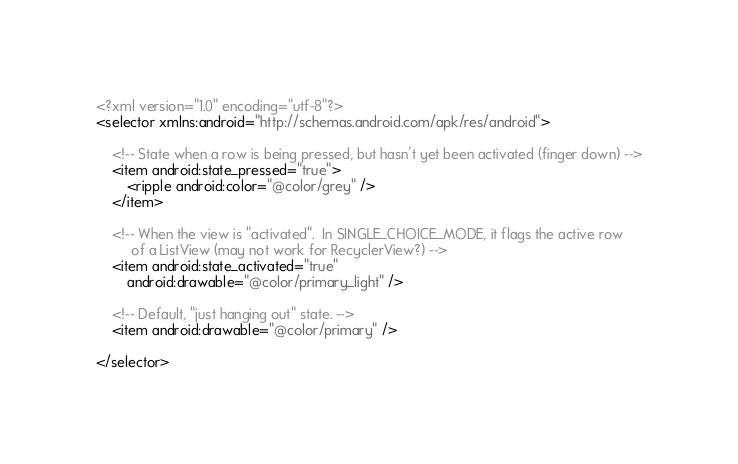<code> <loc_0><loc_0><loc_500><loc_500><_XML_><?xml version="1.0" encoding="utf-8"?>
<selector xmlns:android="http://schemas.android.com/apk/res/android">

    <!-- State when a row is being pressed, but hasn't yet been activated (finger down) -->
    <item android:state_pressed="true">
        <ripple android:color="@color/grey" />
    </item>

    <!-- When the view is "activated".  In SINGLE_CHOICE_MODE, it flags the active row
         of a ListView (may not work for RecyclerView?) -->
    <item android:state_activated="true"
        android:drawable="@color/primary_light" />

    <!-- Default, "just hanging out" state. -->
    <item android:drawable="@color/primary" />

</selector>
</code> 